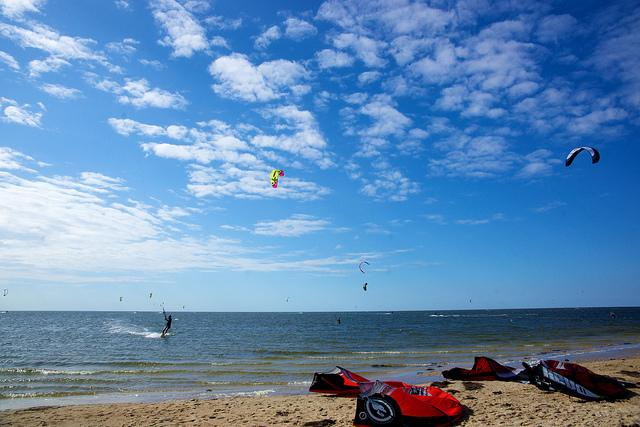What is in the sky? kites 